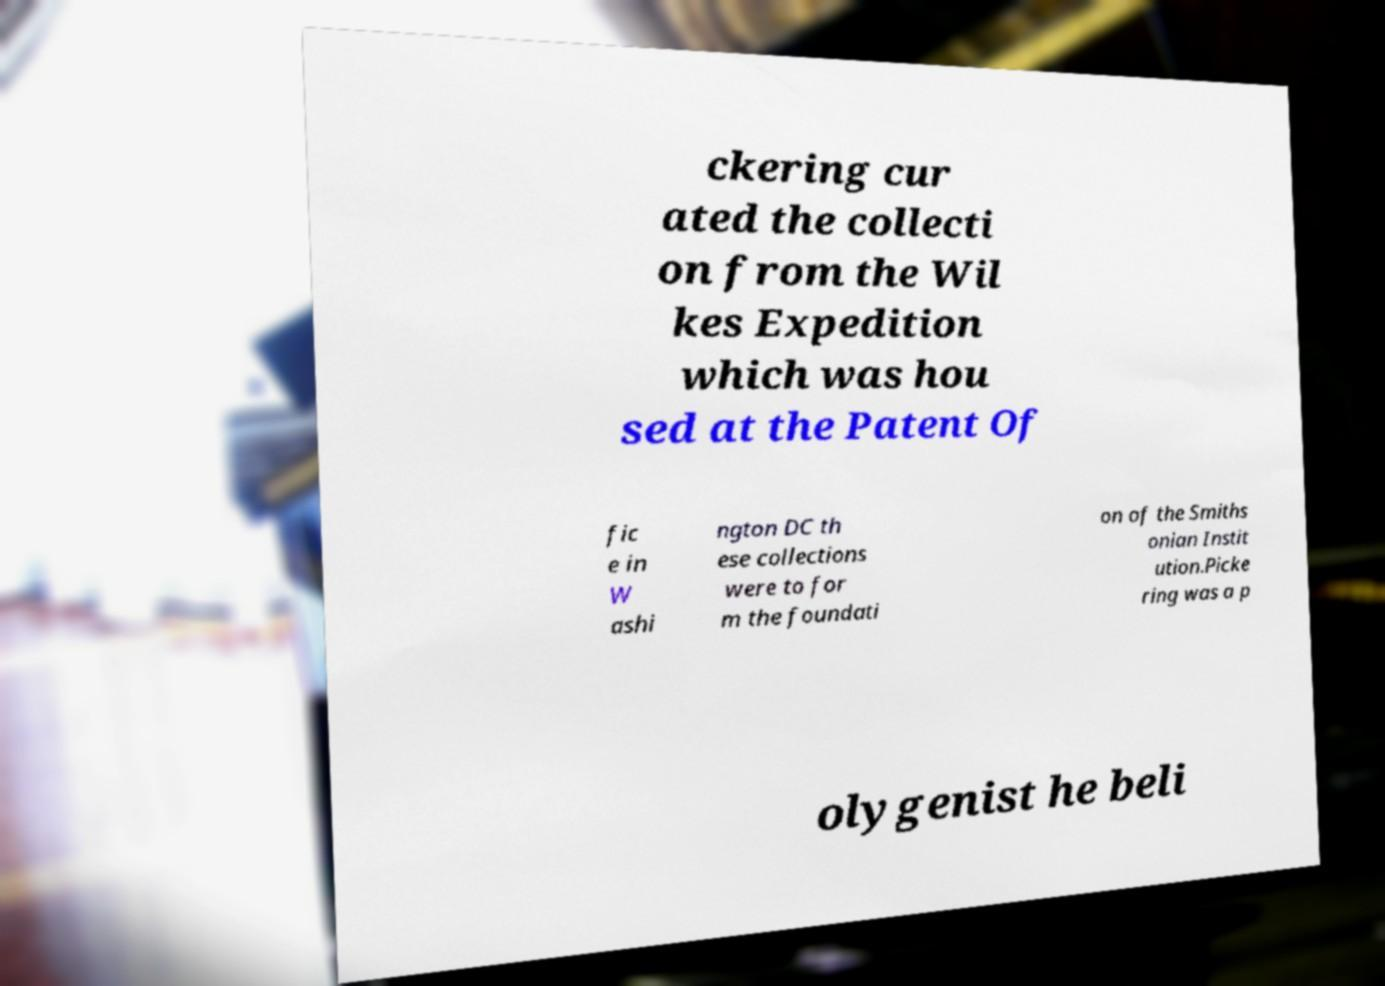There's text embedded in this image that I need extracted. Can you transcribe it verbatim? ckering cur ated the collecti on from the Wil kes Expedition which was hou sed at the Patent Of fic e in W ashi ngton DC th ese collections were to for m the foundati on of the Smiths onian Instit ution.Picke ring was a p olygenist he beli 